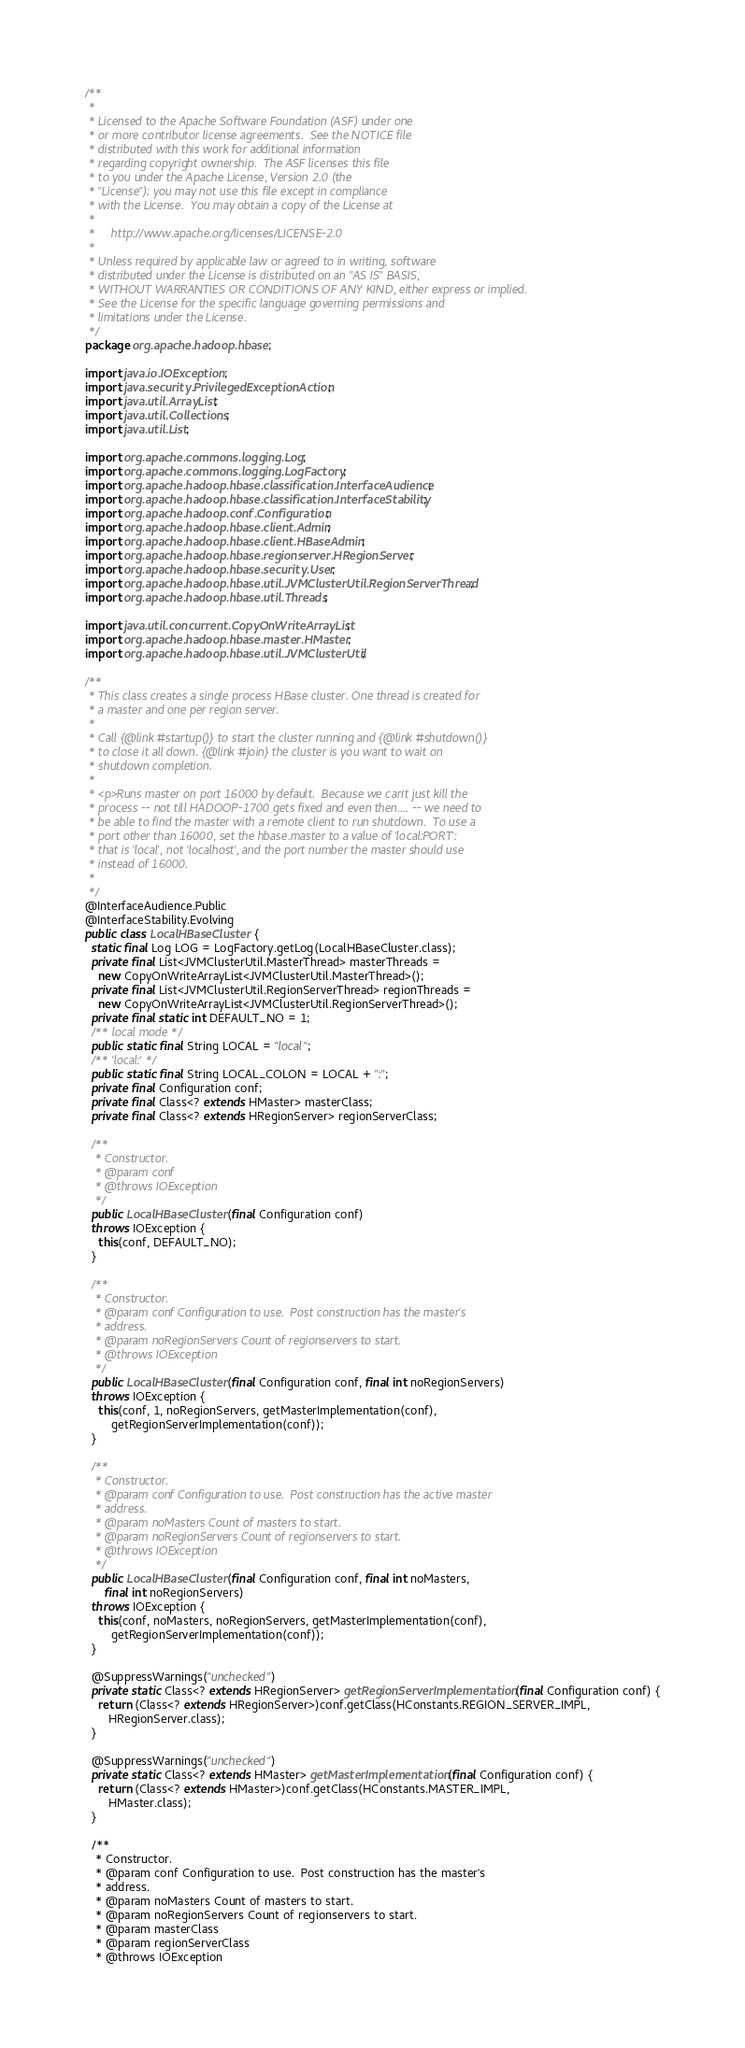<code> <loc_0><loc_0><loc_500><loc_500><_Java_>/**
 *
 * Licensed to the Apache Software Foundation (ASF) under one
 * or more contributor license agreements.  See the NOTICE file
 * distributed with this work for additional information
 * regarding copyright ownership.  The ASF licenses this file
 * to you under the Apache License, Version 2.0 (the
 * "License"); you may not use this file except in compliance
 * with the License.  You may obtain a copy of the License at
 *
 *     http://www.apache.org/licenses/LICENSE-2.0
 *
 * Unless required by applicable law or agreed to in writing, software
 * distributed under the License is distributed on an "AS IS" BASIS,
 * WITHOUT WARRANTIES OR CONDITIONS OF ANY KIND, either express or implied.
 * See the License for the specific language governing permissions and
 * limitations under the License.
 */
package org.apache.hadoop.hbase;

import java.io.IOException;
import java.security.PrivilegedExceptionAction;
import java.util.ArrayList;
import java.util.Collections;
import java.util.List;

import org.apache.commons.logging.Log;
import org.apache.commons.logging.LogFactory;
import org.apache.hadoop.hbase.classification.InterfaceAudience;
import org.apache.hadoop.hbase.classification.InterfaceStability;
import org.apache.hadoop.conf.Configuration;
import org.apache.hadoop.hbase.client.Admin;
import org.apache.hadoop.hbase.client.HBaseAdmin;
import org.apache.hadoop.hbase.regionserver.HRegionServer;
import org.apache.hadoop.hbase.security.User;
import org.apache.hadoop.hbase.util.JVMClusterUtil.RegionServerThread;
import org.apache.hadoop.hbase.util.Threads;

import java.util.concurrent.CopyOnWriteArrayList;
import org.apache.hadoop.hbase.master.HMaster;
import org.apache.hadoop.hbase.util.JVMClusterUtil;

/**
 * This class creates a single process HBase cluster. One thread is created for
 * a master and one per region server.
 *
 * Call {@link #startup()} to start the cluster running and {@link #shutdown()}
 * to close it all down. {@link #join} the cluster is you want to wait on
 * shutdown completion.
 *
 * <p>Runs master on port 16000 by default.  Because we can't just kill the
 * process -- not till HADOOP-1700 gets fixed and even then.... -- we need to
 * be able to find the master with a remote client to run shutdown.  To use a
 * port other than 16000, set the hbase.master to a value of 'local:PORT':
 * that is 'local', not 'localhost', and the port number the master should use
 * instead of 16000.
 *
 */
@InterfaceAudience.Public
@InterfaceStability.Evolving
public class LocalHBaseCluster {
  static final Log LOG = LogFactory.getLog(LocalHBaseCluster.class);
  private final List<JVMClusterUtil.MasterThread> masterThreads =
    new CopyOnWriteArrayList<JVMClusterUtil.MasterThread>();
  private final List<JVMClusterUtil.RegionServerThread> regionThreads =
    new CopyOnWriteArrayList<JVMClusterUtil.RegionServerThread>();
  private final static int DEFAULT_NO = 1;
  /** local mode */
  public static final String LOCAL = "local";
  /** 'local:' */
  public static final String LOCAL_COLON = LOCAL + ":";
  private final Configuration conf;
  private final Class<? extends HMaster> masterClass;
  private final Class<? extends HRegionServer> regionServerClass;

  /**
   * Constructor.
   * @param conf
   * @throws IOException
   */
  public LocalHBaseCluster(final Configuration conf)
  throws IOException {
    this(conf, DEFAULT_NO);
  }

  /**
   * Constructor.
   * @param conf Configuration to use.  Post construction has the master's
   * address.
   * @param noRegionServers Count of regionservers to start.
   * @throws IOException
   */
  public LocalHBaseCluster(final Configuration conf, final int noRegionServers)
  throws IOException {
    this(conf, 1, noRegionServers, getMasterImplementation(conf),
        getRegionServerImplementation(conf));
  }

  /**
   * Constructor.
   * @param conf Configuration to use.  Post construction has the active master
   * address.
   * @param noMasters Count of masters to start.
   * @param noRegionServers Count of regionservers to start.
   * @throws IOException
   */
  public LocalHBaseCluster(final Configuration conf, final int noMasters,
      final int noRegionServers)
  throws IOException {
    this(conf, noMasters, noRegionServers, getMasterImplementation(conf),
        getRegionServerImplementation(conf));
  }

  @SuppressWarnings("unchecked")
  private static Class<? extends HRegionServer> getRegionServerImplementation(final Configuration conf) {
    return (Class<? extends HRegionServer>)conf.getClass(HConstants.REGION_SERVER_IMPL,
       HRegionServer.class);
  }

  @SuppressWarnings("unchecked")
  private static Class<? extends HMaster> getMasterImplementation(final Configuration conf) {
    return (Class<? extends HMaster>)conf.getClass(HConstants.MASTER_IMPL,
       HMaster.class);
  }

  /**
   * Constructor.
   * @param conf Configuration to use.  Post construction has the master's
   * address.
   * @param noMasters Count of masters to start.
   * @param noRegionServers Count of regionservers to start.
   * @param masterClass
   * @param regionServerClass
   * @throws IOException</code> 